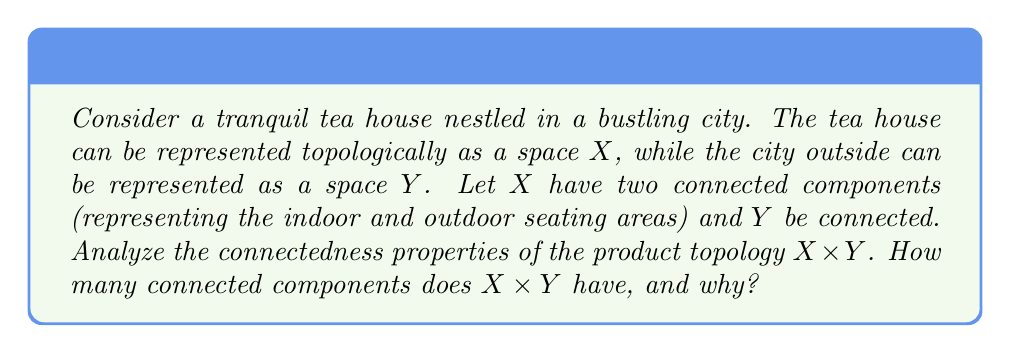Could you help me with this problem? To analyze the connectedness properties of the product topology $X \times Y$, we'll follow these steps:

1) First, recall that for a product topology $X \times Y$, the number of connected components is related to the connectedness of its factor spaces.

2) We're given that:
   - $X$ has two connected components (indoor and outdoor seating areas)
   - $Y$ is connected (representing the continuous space of the city)

3) A key theorem in topology states that for spaces $A$ and $B$, the product $A \times B$ is connected if and only if both $A$ and $B$ are connected.

4) In our case, $Y$ is connected, but $X$ is not. Let's call the two connected components of $X$ as $X_1$ and $X_2$.

5) We can write $X \times Y$ as the union of two sets:
   $$(X \times Y) = (X_1 \times Y) \cup (X_2 \times Y)$$

6) Now, let's analyze each part:
   - $X_1 \times Y$ is the product of a connected component of $X$ with $Y$. Since both factors are connected, $X_1 \times Y$ is connected.
   - Similarly, $X_2 \times Y$ is also connected.

7) Moreover, $X_1 \times Y$ and $X_2 \times Y$ are disjoint, as $X_1$ and $X_2$ are disjoint.

8) In topology, a space that is the union of two disjoint connected subspaces is disconnected and has exactly two connected components.

Therefore, $X \times Y$ has exactly two connected components, mirroring the connectedness structure of $X$.
Answer: The product topology $X \times Y$ has exactly two connected components. 